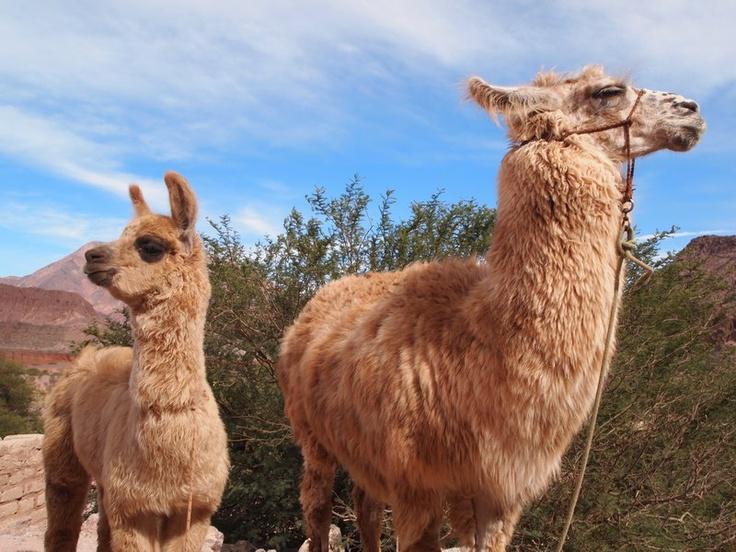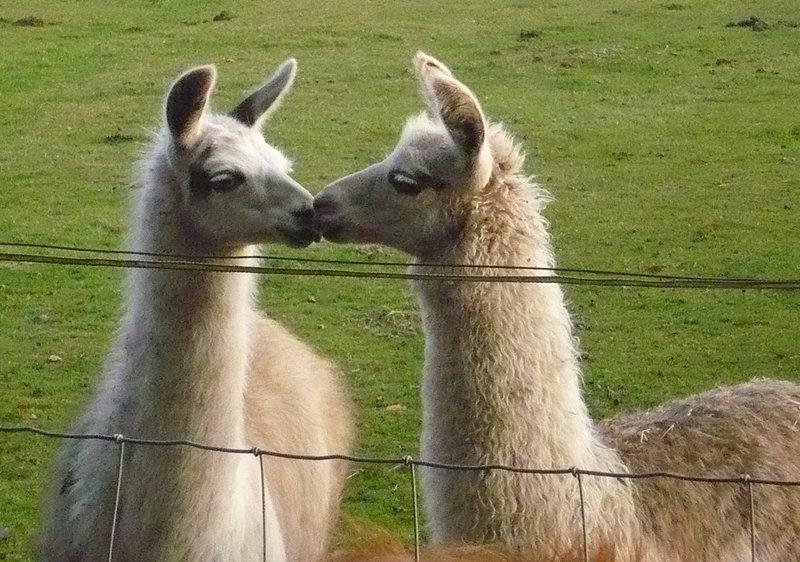The first image is the image on the left, the second image is the image on the right. Evaluate the accuracy of this statement regarding the images: "Each image shows exactly two llamas posed close together in the foreground, and a mountain peak is visible in the background of the left image.". Is it true? Answer yes or no. Yes. The first image is the image on the left, the second image is the image on the right. Examine the images to the left and right. Is the description "There are exactly four llamas." accurate? Answer yes or no. Yes. 